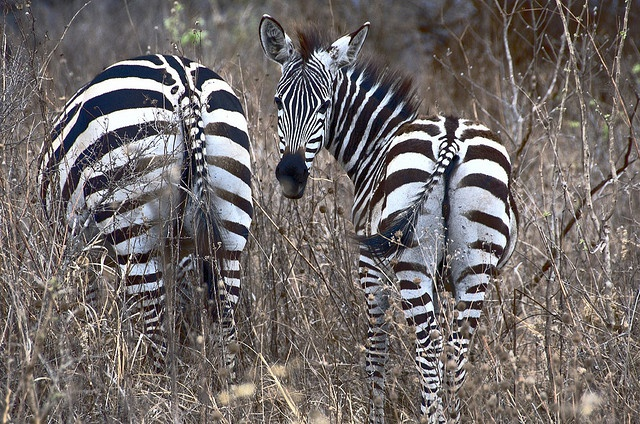Describe the objects in this image and their specific colors. I can see zebra in black, gray, lightgray, and darkgray tones and zebra in black, gray, white, and darkgray tones in this image. 